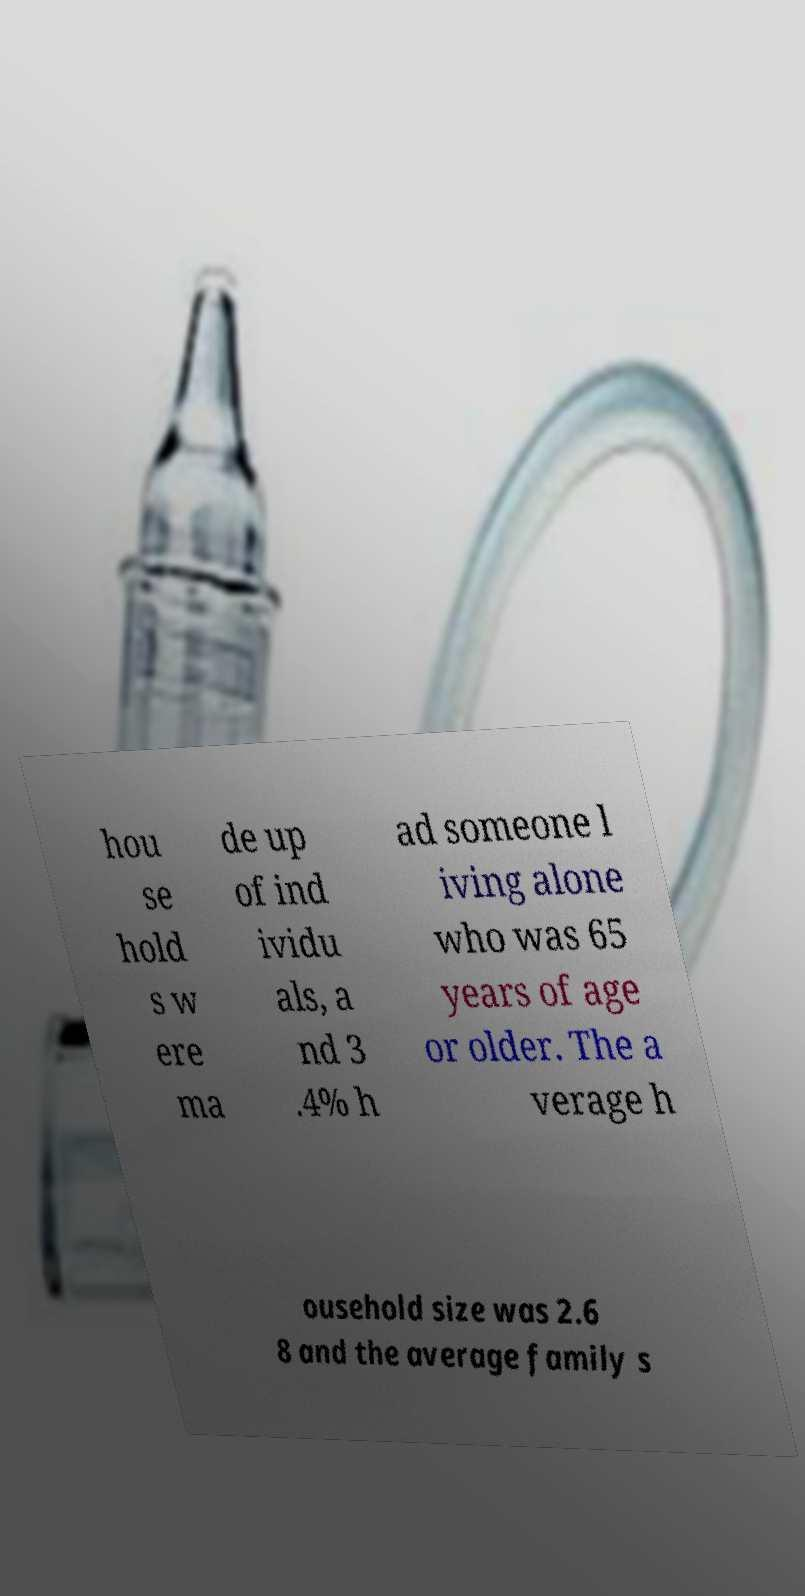Please identify and transcribe the text found in this image. hou se hold s w ere ma de up of ind ividu als, a nd 3 .4% h ad someone l iving alone who was 65 years of age or older. The a verage h ousehold size was 2.6 8 and the average family s 